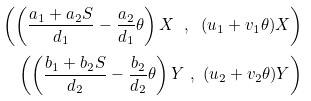<formula> <loc_0><loc_0><loc_500><loc_500>\left ( \left ( \frac { a _ { 1 } + a _ { 2 } S } { d _ { 1 } } - \frac { a _ { 2 } } { d _ { 1 } } \theta \right ) X \text { } , \text { } ( u _ { 1 } + v _ { 1 } \theta ) X \right ) \\ \left ( \left ( \frac { b _ { 1 } + b _ { 2 } S } { d _ { 2 } } - \frac { b _ { 2 } } { d _ { 2 } } \theta \right ) Y \text { } , \text { } ( u _ { 2 } + v _ { 2 } \theta ) Y \right )</formula> 